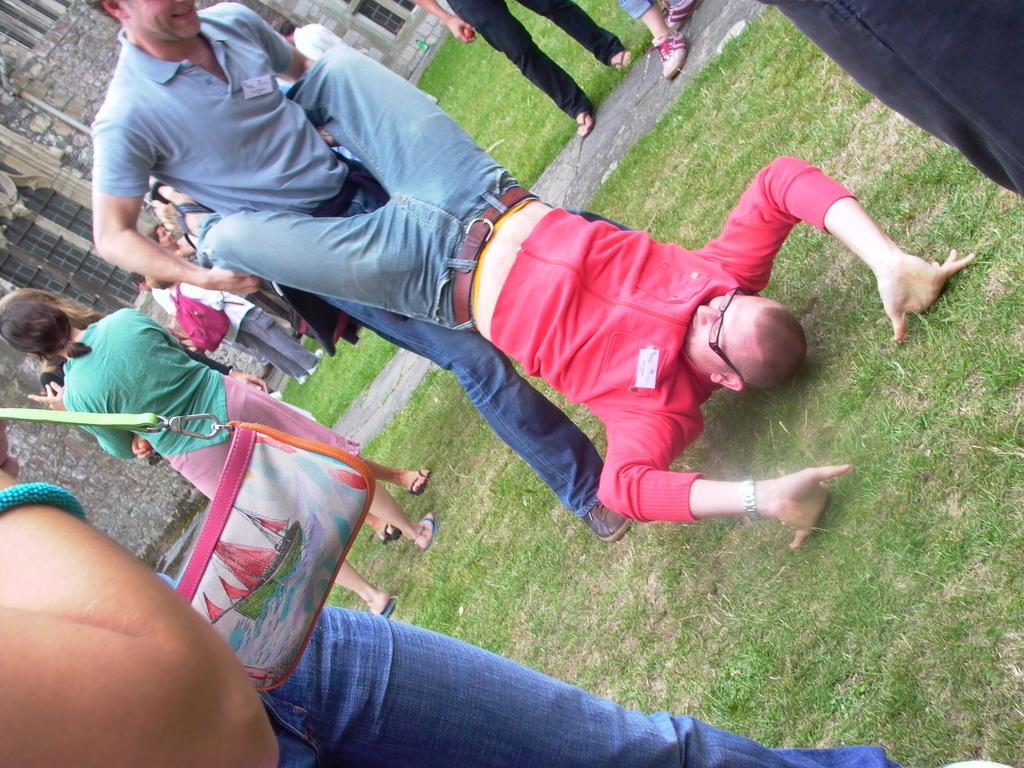Could you give a brief overview of what you see in this image? In this image there are people doing different activities on a ground, in the background there is a building. 